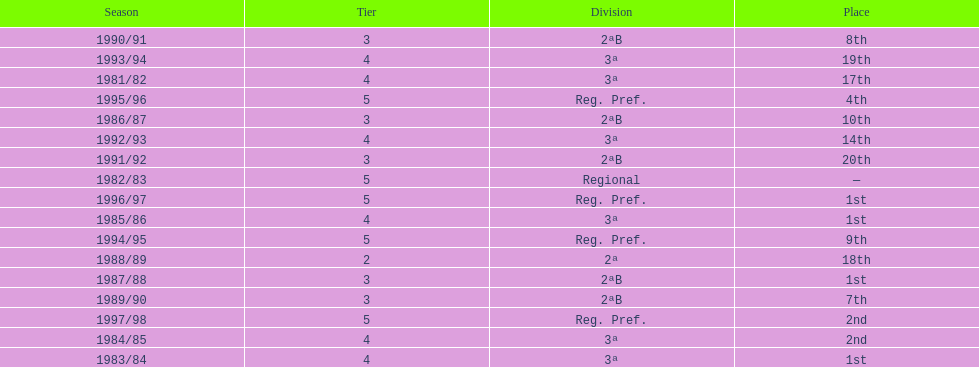What were the number of times second place was earned? 2. 